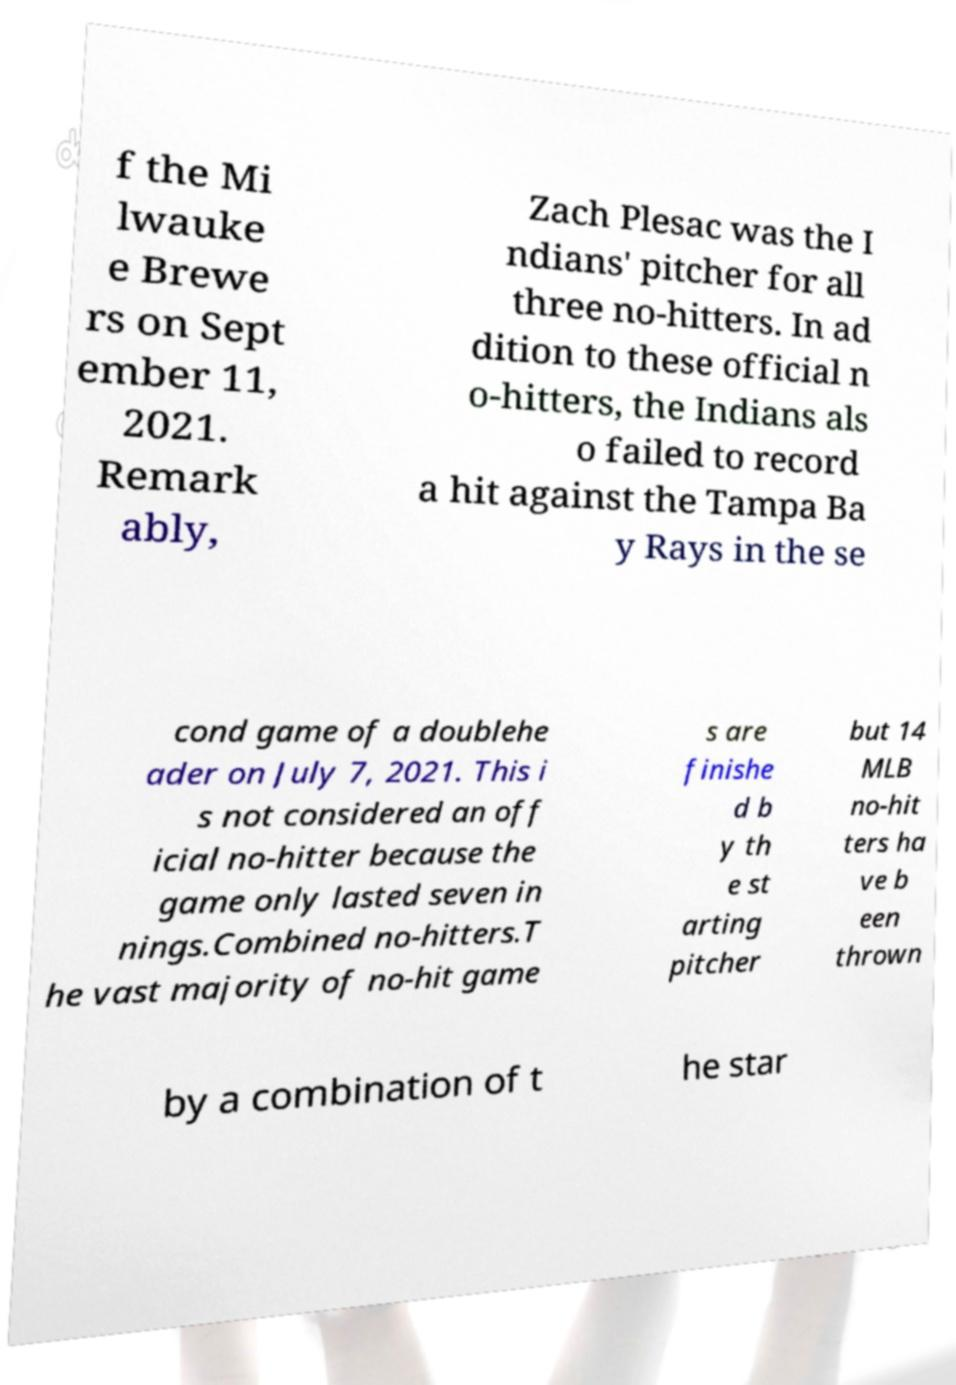Could you assist in decoding the text presented in this image and type it out clearly? f the Mi lwauke e Brewe rs on Sept ember 11, 2021. Remark ably, Zach Plesac was the I ndians' pitcher for all three no-hitters. In ad dition to these official n o-hitters, the Indians als o failed to record a hit against the Tampa Ba y Rays in the se cond game of a doublehe ader on July 7, 2021. This i s not considered an off icial no-hitter because the game only lasted seven in nings.Combined no-hitters.T he vast majority of no-hit game s are finishe d b y th e st arting pitcher but 14 MLB no-hit ters ha ve b een thrown by a combination of t he star 